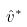Convert formula to latex. <formula><loc_0><loc_0><loc_500><loc_500>\hat { v } ^ { * }</formula> 